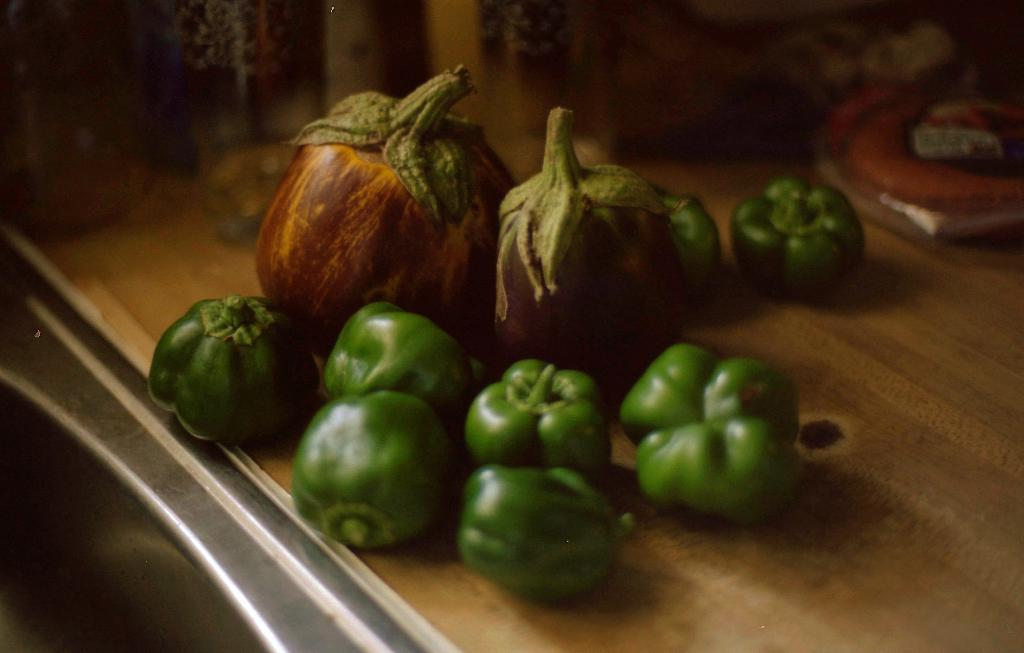What type of food is present on the wooden surface in the image? There are vegetables on a wooden surface in the image. Can you describe the objects on either side of the image? There is an object on the right side and an object on the left side of the image. What can be said about the background of the image? The background of the image is blurred. What type of cloud is visible in the middle of the image? There is no cloud visible in the image, as the background is blurred and no clouds are mentioned in the facts. 